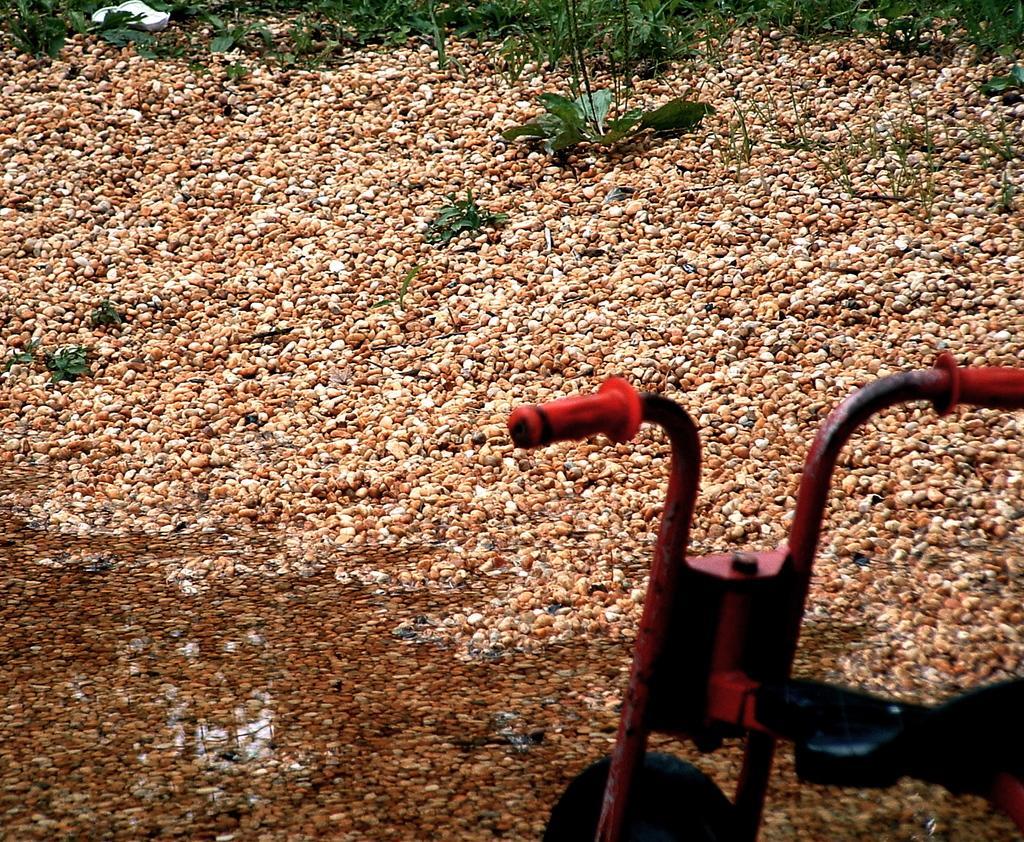In one or two sentences, can you explain what this image depicts? In this image, on the right, there is a vehicle and in the background, there are plants. At the bottom, there are stones. 